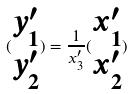<formula> <loc_0><loc_0><loc_500><loc_500>( \begin{matrix} y _ { 1 } ^ { \prime } \\ y _ { 2 } ^ { \prime } \end{matrix} ) = \frac { 1 } { x _ { 3 } ^ { \prime } } ( \begin{matrix} x _ { 1 } ^ { \prime } \\ x _ { 2 } ^ { \prime } \end{matrix} )</formula> 